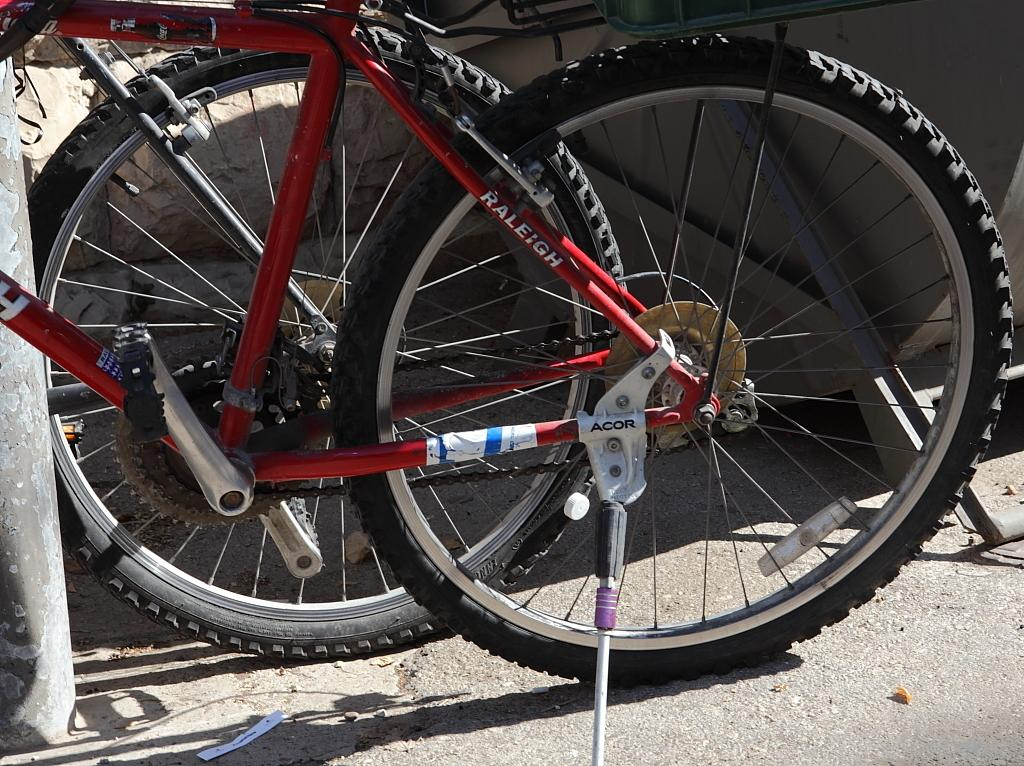How many bicycles are in the image? There are two bicycles in the image. What feature do the bicycles have in common? The bicycles have wheels. Where are the bicycles located in the image? The bicycles are on the road. What can be seen on the left side of the image? There is a pole on the left side of the image. What is visible in the background of the image? There is a wall and an object in the background of the image. What type of oranges are being used to teach a class in the image? There are no oranges or class present in the image. How is the brush being used in the image? There is no brush present in the image. 